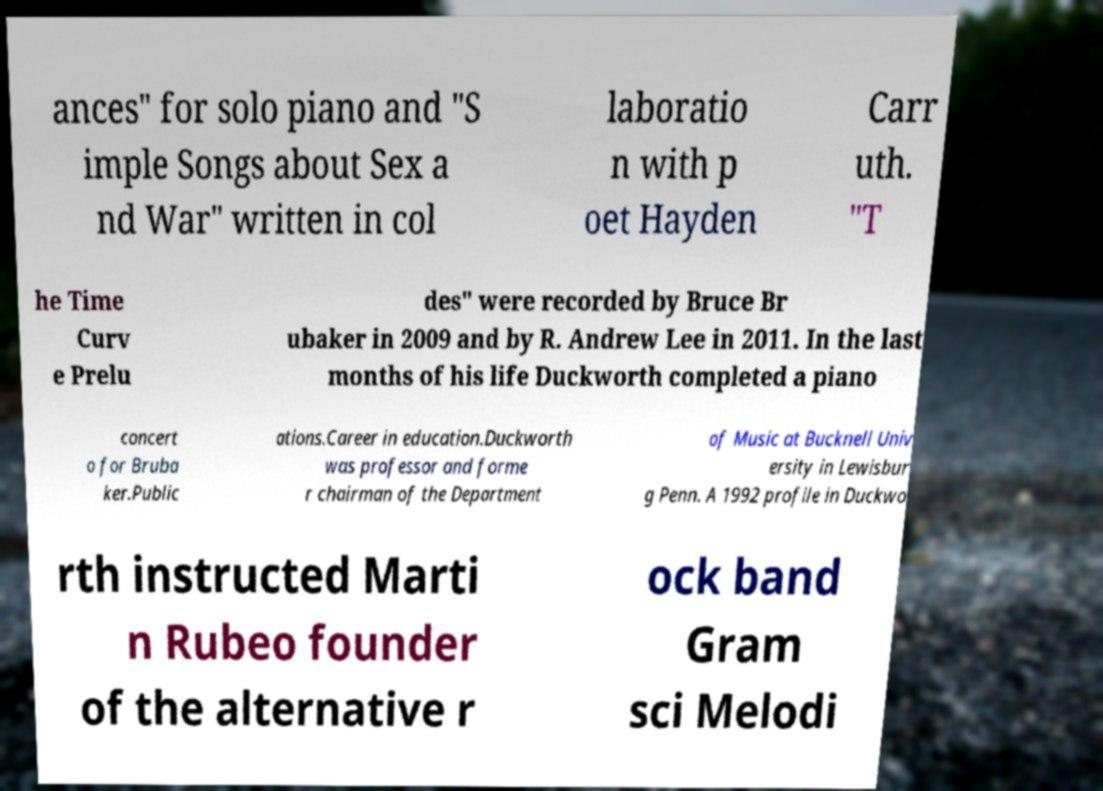Please read and relay the text visible in this image. What does it say? ances" for solo piano and "S imple Songs about Sex a nd War" written in col laboratio n with p oet Hayden Carr uth. "T he Time Curv e Prelu des" were recorded by Bruce Br ubaker in 2009 and by R. Andrew Lee in 2011. In the last months of his life Duckworth completed a piano concert o for Bruba ker.Public ations.Career in education.Duckworth was professor and forme r chairman of the Department of Music at Bucknell Univ ersity in Lewisbur g Penn. A 1992 profile in Duckwo rth instructed Marti n Rubeo founder of the alternative r ock band Gram sci Melodi 